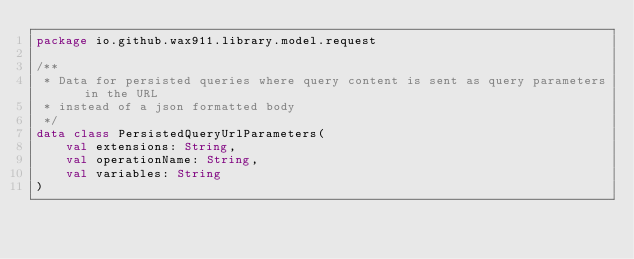Convert code to text. <code><loc_0><loc_0><loc_500><loc_500><_Kotlin_>package io.github.wax911.library.model.request

/**
 * Data for persisted queries where query content is sent as query parameters in the URL
 * instead of a json formatted body
 */
data class PersistedQueryUrlParameters(
    val extensions: String,
    val operationName: String,
    val variables: String
)</code> 